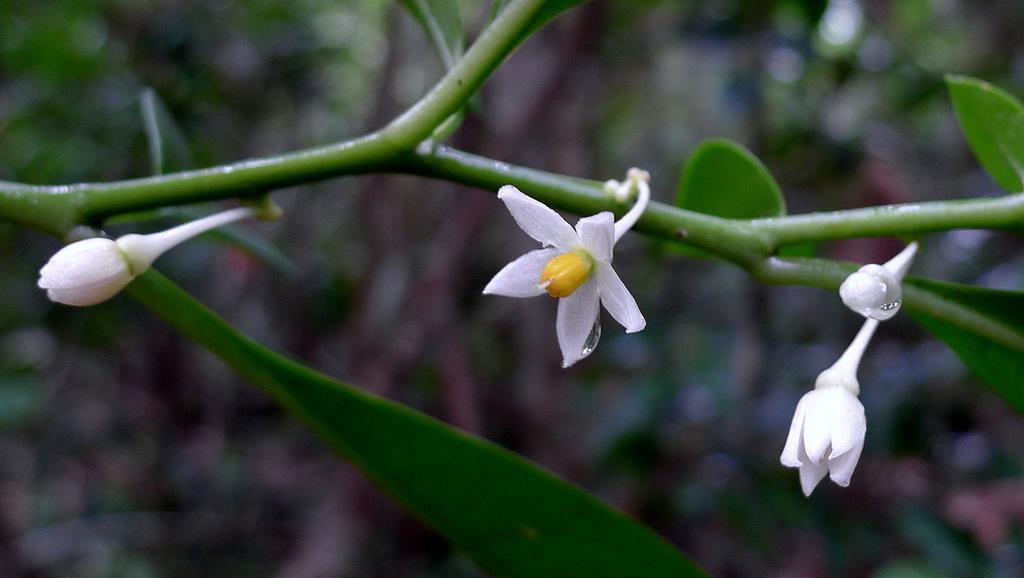Can you describe this image briefly? In the foreground of the picture there are flowers, leaves and stem of a plant. The background is green. 